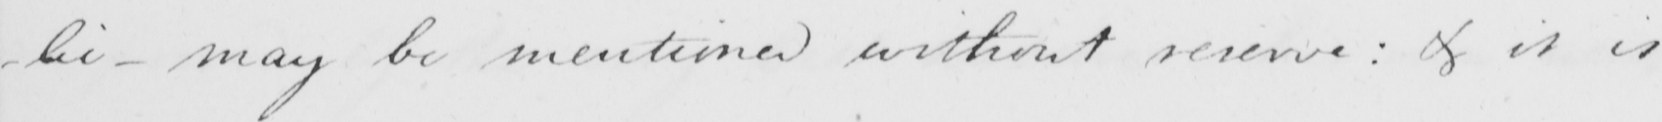Please provide the text content of this handwritten line. -lic - may be mentioned without reserve :  & it is 